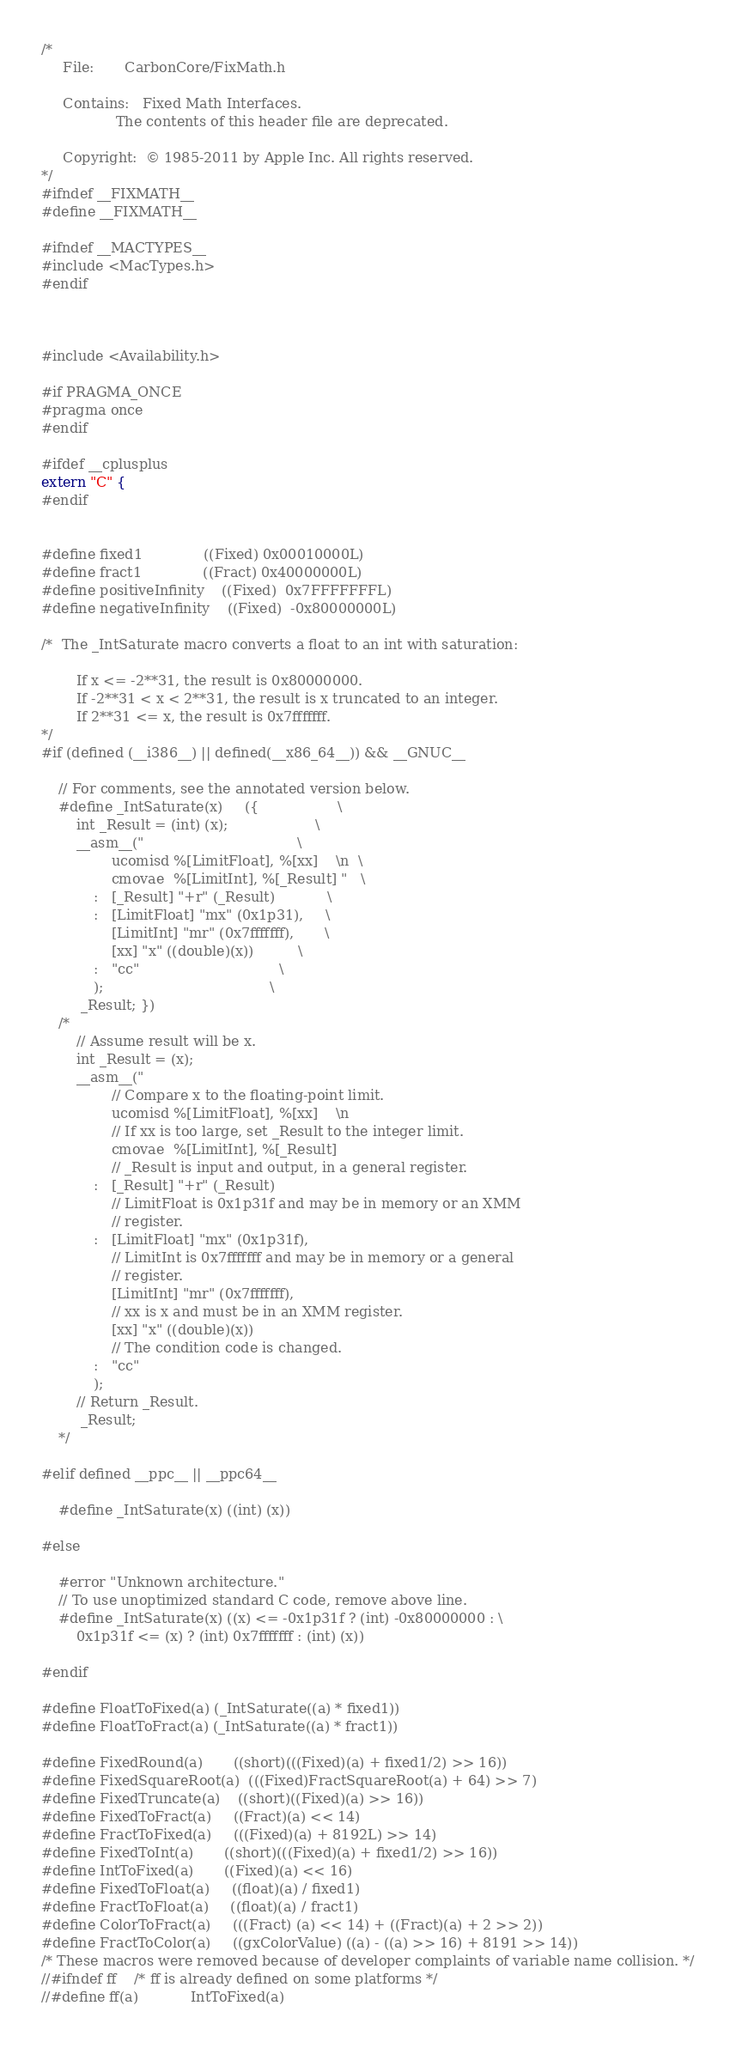<code> <loc_0><loc_0><loc_500><loc_500><_C_>/*
     File:       CarbonCore/FixMath.h
 
     Contains:   Fixed Math Interfaces.
                 The contents of this header file are deprecated.
 
     Copyright:  © 1985-2011 by Apple Inc. All rights reserved.
*/
#ifndef __FIXMATH__
#define __FIXMATH__

#ifndef __MACTYPES__
#include <MacTypes.h>
#endif



#include <Availability.h>

#if PRAGMA_ONCE
#pragma once
#endif

#ifdef __cplusplus
extern "C" {
#endif


#define fixed1              ((Fixed) 0x00010000L)
#define fract1              ((Fract) 0x40000000L)
#define positiveInfinity    ((Fixed)  0x7FFFFFFFL)
#define negativeInfinity    ((Fixed)  -0x80000000L)

/*  The _IntSaturate macro converts a float to an int with saturation:

        If x <= -2**31, the result is 0x80000000.
        If -2**31 < x < 2**31, the result is x truncated to an integer.
        If 2**31 <= x, the result is 0x7fffffff.
*/
#if (defined (__i386__) || defined(__x86_64__)) && __GNUC__

    // For comments, see the annotated version below.
    #define _IntSaturate(x)     ({                  \
        int _Result = (int) (x);                    \
        __asm__("                                   \
                ucomisd %[LimitFloat], %[xx]    \n  \
                cmovae  %[LimitInt], %[_Result] "   \
            :   [_Result] "+r" (_Result)            \
            :   [LimitFloat] "mx" (0x1p31),     \
                [LimitInt] "mr" (0x7fffffff),       \
                [xx] "x" ((double)(x))          \
            :   "cc"                                \
            );                                      \
         _Result; })
    /*
        // Assume result will be x.
        int _Result = (x);
        __asm__("
                // Compare x to the floating-point limit.
                ucomisd %[LimitFloat], %[xx]    \n
                // If xx is too large, set _Result to the integer limit.
                cmovae  %[LimitInt], %[_Result]
                // _Result is input and output, in a general register.
            :   [_Result] "+r" (_Result)
                // LimitFloat is 0x1p31f and may be in memory or an XMM
                // register.
            :   [LimitFloat] "mx" (0x1p31f),
                // LimitInt is 0x7fffffff and may be in memory or a general
                // register.
                [LimitInt] "mr" (0x7fffffff),
                // xx is x and must be in an XMM register.
                [xx] "x" ((double)(x))
                // The condition code is changed.
            :   "cc"
            );
        // Return _Result.
         _Result;
    */

#elif defined __ppc__ || __ppc64__

    #define _IntSaturate(x) ((int) (x))

#else

    #error "Unknown architecture."
    // To use unoptimized standard C code, remove above line.
    #define _IntSaturate(x) ((x) <= -0x1p31f ? (int) -0x80000000 : \
        0x1p31f <= (x) ? (int) 0x7fffffff : (int) (x))

#endif

#define FloatToFixed(a) (_IntSaturate((a) * fixed1))
#define FloatToFract(a) (_IntSaturate((a) * fract1))

#define FixedRound(a)       ((short)(((Fixed)(a) + fixed1/2) >> 16))
#define FixedSquareRoot(a)  (((Fixed)FractSquareRoot(a) + 64) >> 7)
#define FixedTruncate(a)    ((short)((Fixed)(a) >> 16))
#define FixedToFract(a)     ((Fract)(a) << 14)
#define FractToFixed(a)     (((Fixed)(a) + 8192L) >> 14)
#define FixedToInt(a)       ((short)(((Fixed)(a) + fixed1/2) >> 16))
#define IntToFixed(a)       ((Fixed)(a) << 16)
#define FixedToFloat(a)     ((float)(a) / fixed1)
#define FractToFloat(a)     ((float)(a) / fract1)
#define ColorToFract(a)     (((Fract) (a) << 14) + ((Fract)(a) + 2 >> 2))
#define FractToColor(a)     ((gxColorValue) ((a) - ((a) >> 16) + 8191 >> 14))
/* These macros were removed because of developer complaints of variable name collision. */
//#ifndef ff    /* ff is already defined on some platforms */
//#define ff(a)            IntToFixed(a)</code> 